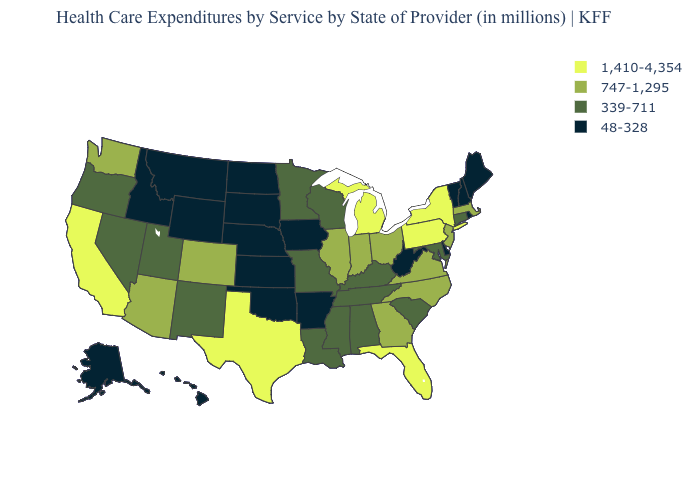Name the states that have a value in the range 747-1,295?
Be succinct. Arizona, Colorado, Georgia, Illinois, Indiana, Massachusetts, New Jersey, North Carolina, Ohio, Virginia, Washington. Name the states that have a value in the range 48-328?
Be succinct. Alaska, Arkansas, Delaware, Hawaii, Idaho, Iowa, Kansas, Maine, Montana, Nebraska, New Hampshire, North Dakota, Oklahoma, Rhode Island, South Dakota, Vermont, West Virginia, Wyoming. Which states have the lowest value in the USA?
Concise answer only. Alaska, Arkansas, Delaware, Hawaii, Idaho, Iowa, Kansas, Maine, Montana, Nebraska, New Hampshire, North Dakota, Oklahoma, Rhode Island, South Dakota, Vermont, West Virginia, Wyoming. What is the highest value in the MidWest ?
Answer briefly. 1,410-4,354. Name the states that have a value in the range 1,410-4,354?
Keep it brief. California, Florida, Michigan, New York, Pennsylvania, Texas. Among the states that border Arkansas , does Texas have the highest value?
Concise answer only. Yes. Does Illinois have the lowest value in the MidWest?
Answer briefly. No. What is the highest value in states that border Montana?
Write a very short answer. 48-328. Does Arizona have the lowest value in the USA?
Be succinct. No. What is the highest value in states that border Montana?
Give a very brief answer. 48-328. Name the states that have a value in the range 48-328?
Quick response, please. Alaska, Arkansas, Delaware, Hawaii, Idaho, Iowa, Kansas, Maine, Montana, Nebraska, New Hampshire, North Dakota, Oklahoma, Rhode Island, South Dakota, Vermont, West Virginia, Wyoming. What is the value of Wisconsin?
Give a very brief answer. 339-711. Name the states that have a value in the range 1,410-4,354?
Answer briefly. California, Florida, Michigan, New York, Pennsylvania, Texas. Which states hav the highest value in the Northeast?
Quick response, please. New York, Pennsylvania. Does the map have missing data?
Write a very short answer. No. 